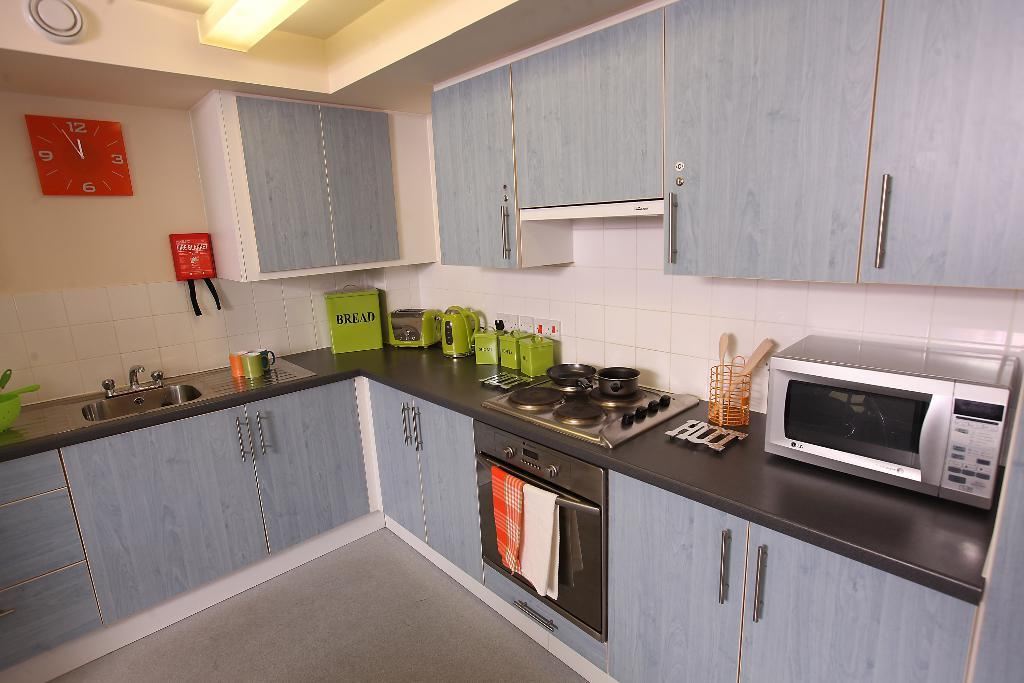<image>
Relay a brief, clear account of the picture shown. Green canisters are on a kitchen counter and one of them is marked BREAD 